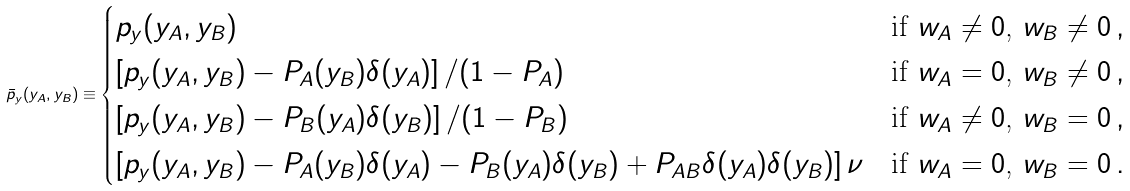Convert formula to latex. <formula><loc_0><loc_0><loc_500><loc_500>\bar { p } _ { y } ( y _ { A } , y _ { B } ) \equiv \begin{cases} p _ { y } ( y _ { A } , y _ { B } ) & \text {if $w_{A} \neq 0$, $w_{B} \neq 0$} \, , \\ \left [ p _ { y } ( y _ { A } , y _ { B } ) - P _ { A } ( y _ { B } ) \delta ( y _ { A } ) \right ] / ( 1 - P _ { A } ) & \text {if $w_{A} = 0$, $w_{B} \neq 0$} \, , \\ \left [ p _ { y } ( y _ { A } , y _ { B } ) - P _ { B } ( y _ { A } ) \delta ( y _ { B } ) \right ] / ( 1 - P _ { B } ) & \text {if $w_{A} \neq 0$, $w_{B} = 0$} \, , \\ \left [ p _ { y } ( y _ { A } , y _ { B } ) - P _ { A } ( y _ { B } ) \delta ( y _ { A } ) - P _ { B } ( y _ { A } ) \delta ( y _ { B } ) + P _ { A B } \delta ( y _ { A } ) \delta ( y _ { B } ) \right ] \nu & \text {if $w_{A} = 0$, $w_{B} = 0$} \, . \end{cases}</formula> 